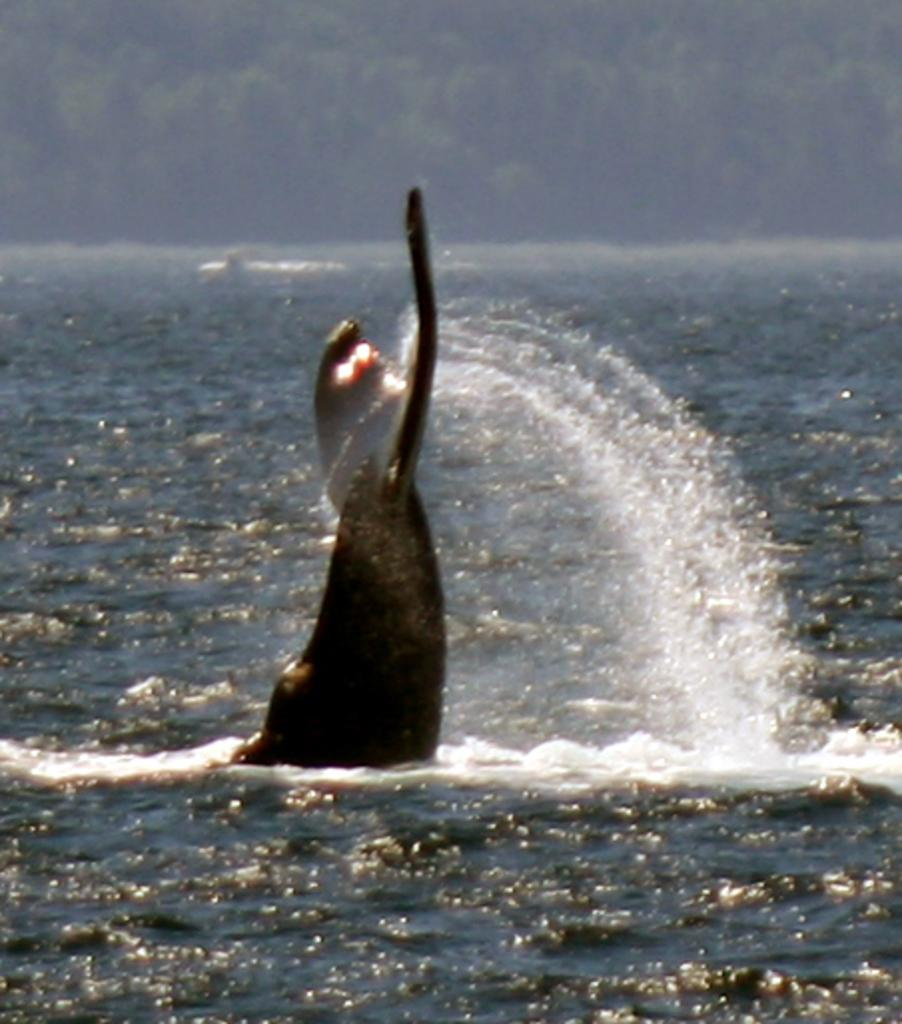What is visible in the image? There is water visible in the image. What can be seen in the background of the image? There are trees in the background of the image. What type of basin is located on top of the trees in the image? There is no basin present in the image, and the trees are in the background, not on top of the water. 